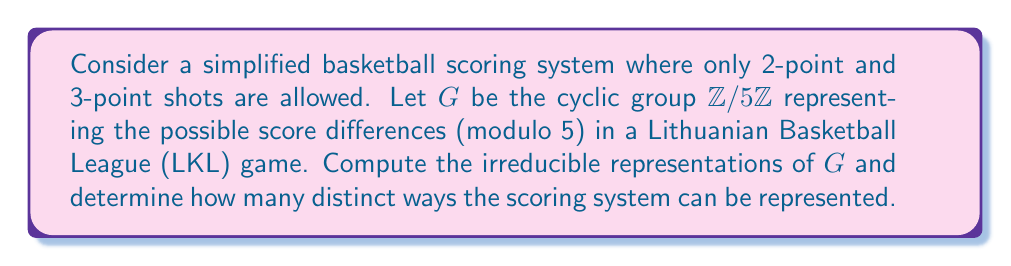Can you solve this math problem? Let's approach this step-by-step:

1) The group $G = \mathbb{Z}/5\mathbb{Z}$ is a cyclic group of order 5. Its elements can be represented as $\{0, 1, 2, 3, 4\}$ under addition modulo 5.

2) For a cyclic group of order $n$, there are exactly $n$ irreducible representations, each of dimension 1. These representations are given by the characters:

   $$\chi_k(g) = e^{2\pi i kg/n}$$

   where $k = 0, 1, ..., n-1$ and $g$ is an element of the group.

3) In our case, $n = 5$, so we have 5 irreducible representations:

   For $k = 0$: $\chi_0(g) = 1$ for all $g$
   For $k = 1$: $\chi_1(g) = e^{2\pi i g/5}$
   For $k = 2$: $\chi_2(g) = e^{4\pi i g/5}$
   For $k = 3$: $\chi_3(g) = e^{6\pi i g/5}$
   For $k = 4$: $\chi_4(g) = e^{8\pi i g/5}$

4) These representations correspond to different ways the scoring system can affect the score difference:

   $\chi_0$: Trivial representation (no change in score difference)
   $\chi_1$: Representation for 2-point shots (changes score difference by 2)
   $\chi_2$: Representation for 4-point plays (rare, but possible)
   $\chi_3$: Representation for 3-point shots
   $\chi_4$: Representation for 1-point plays (e.g., free throws)

5) Each of these representations is 1-dimensional and irreducible.

Therefore, there are 5 distinct irreducible representations of the group $G$, corresponding to 5 different ways the scoring system can be represented in terms of its effect on the score difference modulo 5.
Answer: 5 irreducible representations 